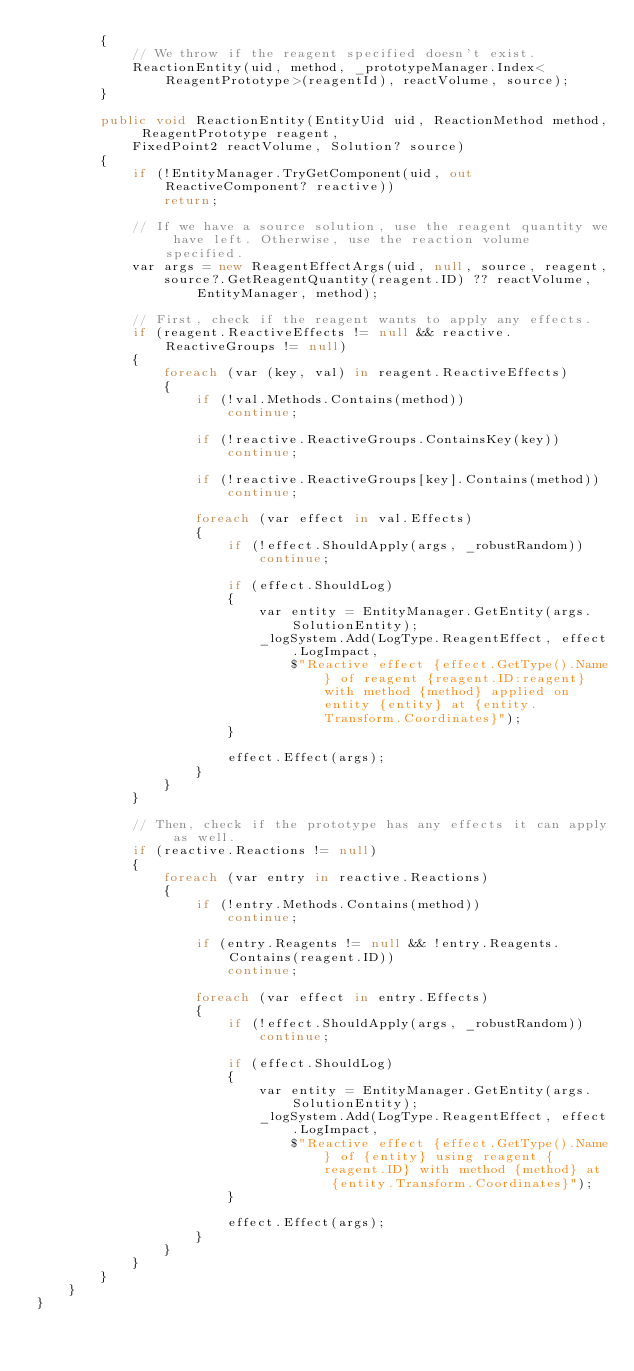<code> <loc_0><loc_0><loc_500><loc_500><_C#_>        {
            // We throw if the reagent specified doesn't exist.
            ReactionEntity(uid, method, _prototypeManager.Index<ReagentPrototype>(reagentId), reactVolume, source);
        }

        public void ReactionEntity(EntityUid uid, ReactionMethod method, ReagentPrototype reagent,
            FixedPoint2 reactVolume, Solution? source)
        {
            if (!EntityManager.TryGetComponent(uid, out ReactiveComponent? reactive))
                return;

            // If we have a source solution, use the reagent quantity we have left. Otherwise, use the reaction volume specified.
            var args = new ReagentEffectArgs(uid, null, source, reagent,
                source?.GetReagentQuantity(reagent.ID) ?? reactVolume, EntityManager, method);

            // First, check if the reagent wants to apply any effects.
            if (reagent.ReactiveEffects != null && reactive.ReactiveGroups != null)
            {
                foreach (var (key, val) in reagent.ReactiveEffects)
                {
                    if (!val.Methods.Contains(method))
                        continue;

                    if (!reactive.ReactiveGroups.ContainsKey(key))
                        continue;

                    if (!reactive.ReactiveGroups[key].Contains(method))
                        continue;

                    foreach (var effect in val.Effects)
                    {
                        if (!effect.ShouldApply(args, _robustRandom))
                            continue;

                        if (effect.ShouldLog)
                        {
                            var entity = EntityManager.GetEntity(args.SolutionEntity);
                            _logSystem.Add(LogType.ReagentEffect, effect.LogImpact,
                                $"Reactive effect {effect.GetType().Name} of reagent {reagent.ID:reagent} with method {method} applied on entity {entity} at {entity.Transform.Coordinates}");
                        }

                        effect.Effect(args);
                    }
                }
            }

            // Then, check if the prototype has any effects it can apply as well.
            if (reactive.Reactions != null)
            {
                foreach (var entry in reactive.Reactions)
                {
                    if (!entry.Methods.Contains(method))
                        continue;

                    if (entry.Reagents != null && !entry.Reagents.Contains(reagent.ID))
                        continue;

                    foreach (var effect in entry.Effects)
                    {
                        if (!effect.ShouldApply(args, _robustRandom))
                            continue;

                        if (effect.ShouldLog)
                        {
                            var entity = EntityManager.GetEntity(args.SolutionEntity);
                            _logSystem.Add(LogType.ReagentEffect, effect.LogImpact,
                                $"Reactive effect {effect.GetType().Name} of {entity} using reagent {reagent.ID} with method {method} at {entity.Transform.Coordinates}");
                        }

                        effect.Effect(args);
                    }
                }
            }
        }
    }
}
</code> 